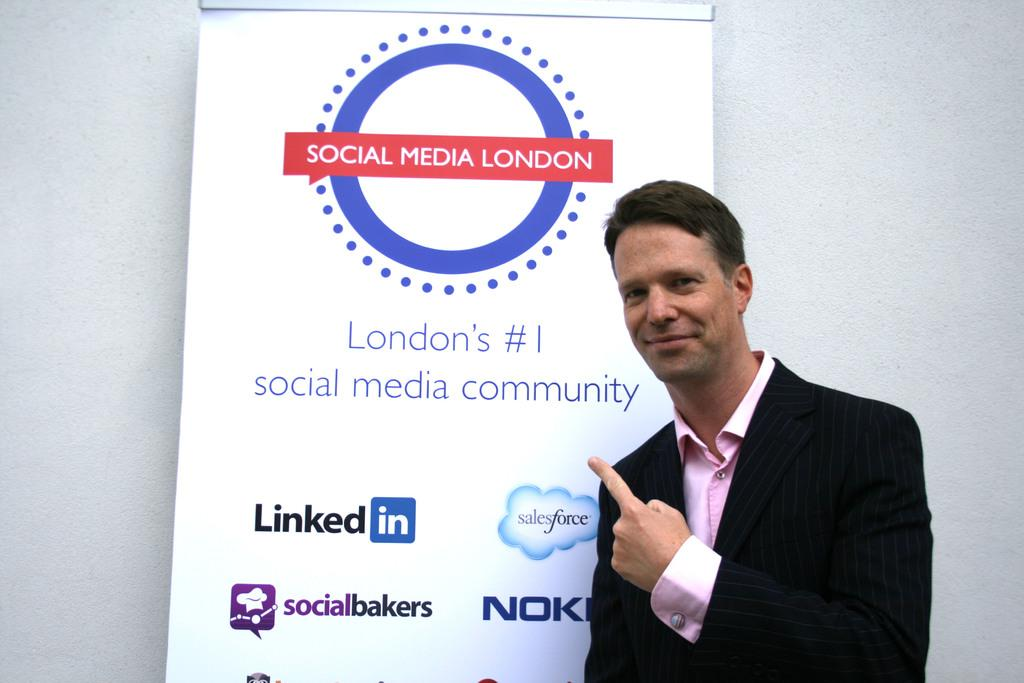What is the main subject of the image? There is a man standing in the image. What can be seen in the background of the image? There is a poster in the background of the image. What is featured on the poster? There is text on the poster. Can you describe the text visible behind the poster? There is text visible behind the poster. How many snakes are slithering around the man's feet in the image? There are no snakes present in the image; the man is standing alone. What type of pen is the man holding in the image? There is no pen visible in the image; the man is not holding any object. 